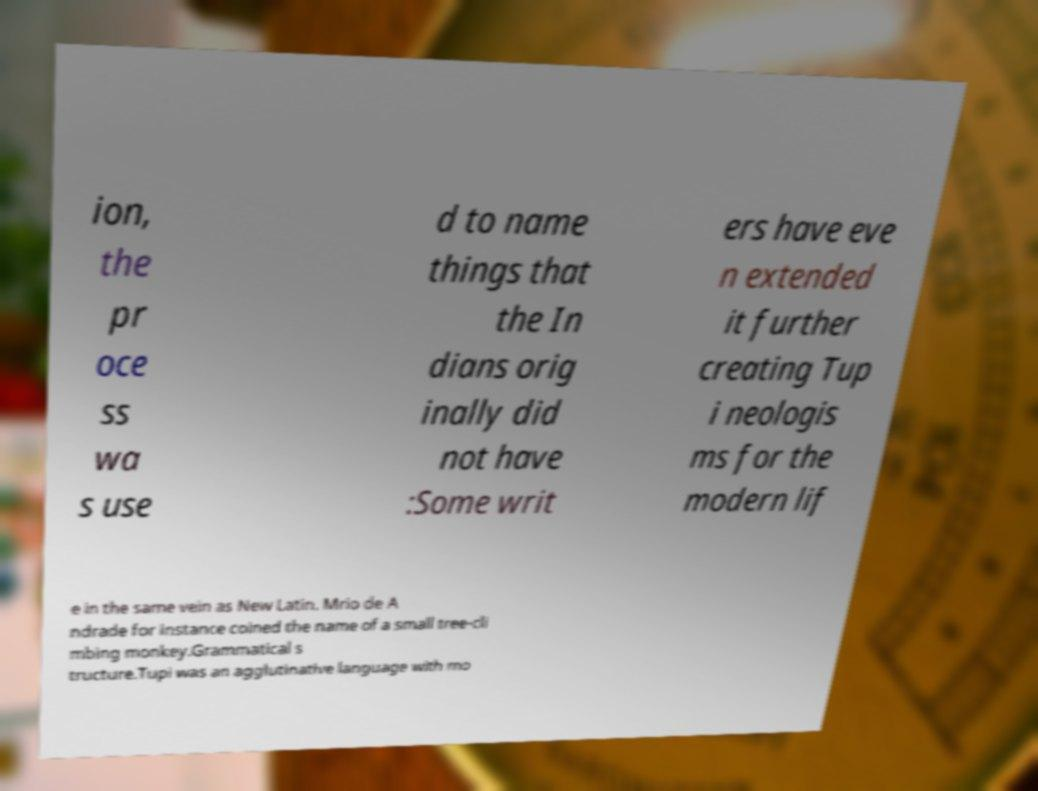Could you extract and type out the text from this image? ion, the pr oce ss wa s use d to name things that the In dians orig inally did not have :Some writ ers have eve n extended it further creating Tup i neologis ms for the modern lif e in the same vein as New Latin. Mrio de A ndrade for instance coined the name of a small tree-cli mbing monkey.Grammatical s tructure.Tupi was an agglutinative language with mo 